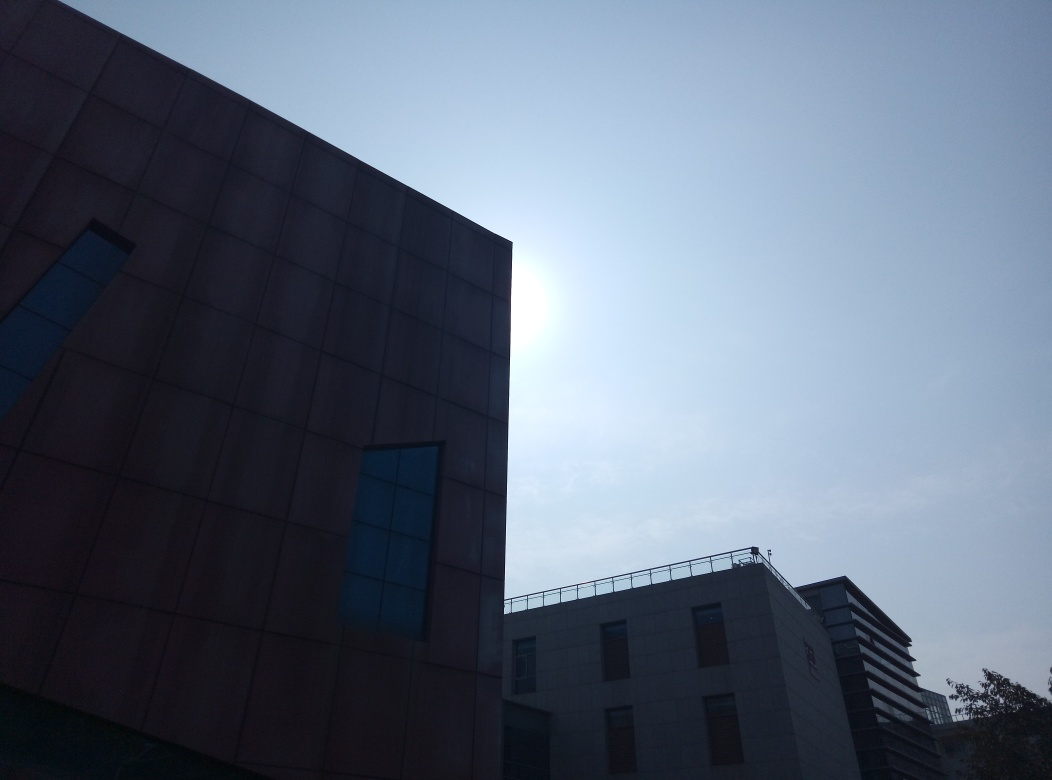What emotions does the interplay of light and shadow in this image evoke? The stark contrasts between the bright illuminated sky and the darker, enigmatic facade of the buildings evoke feelings of solitude and quiet contemplation. The image’s mood is contemplative, bordered on the surreal, suggesting a serene yet slightly melancholic atmosphere that could be reflective of modern architectural isolation. 